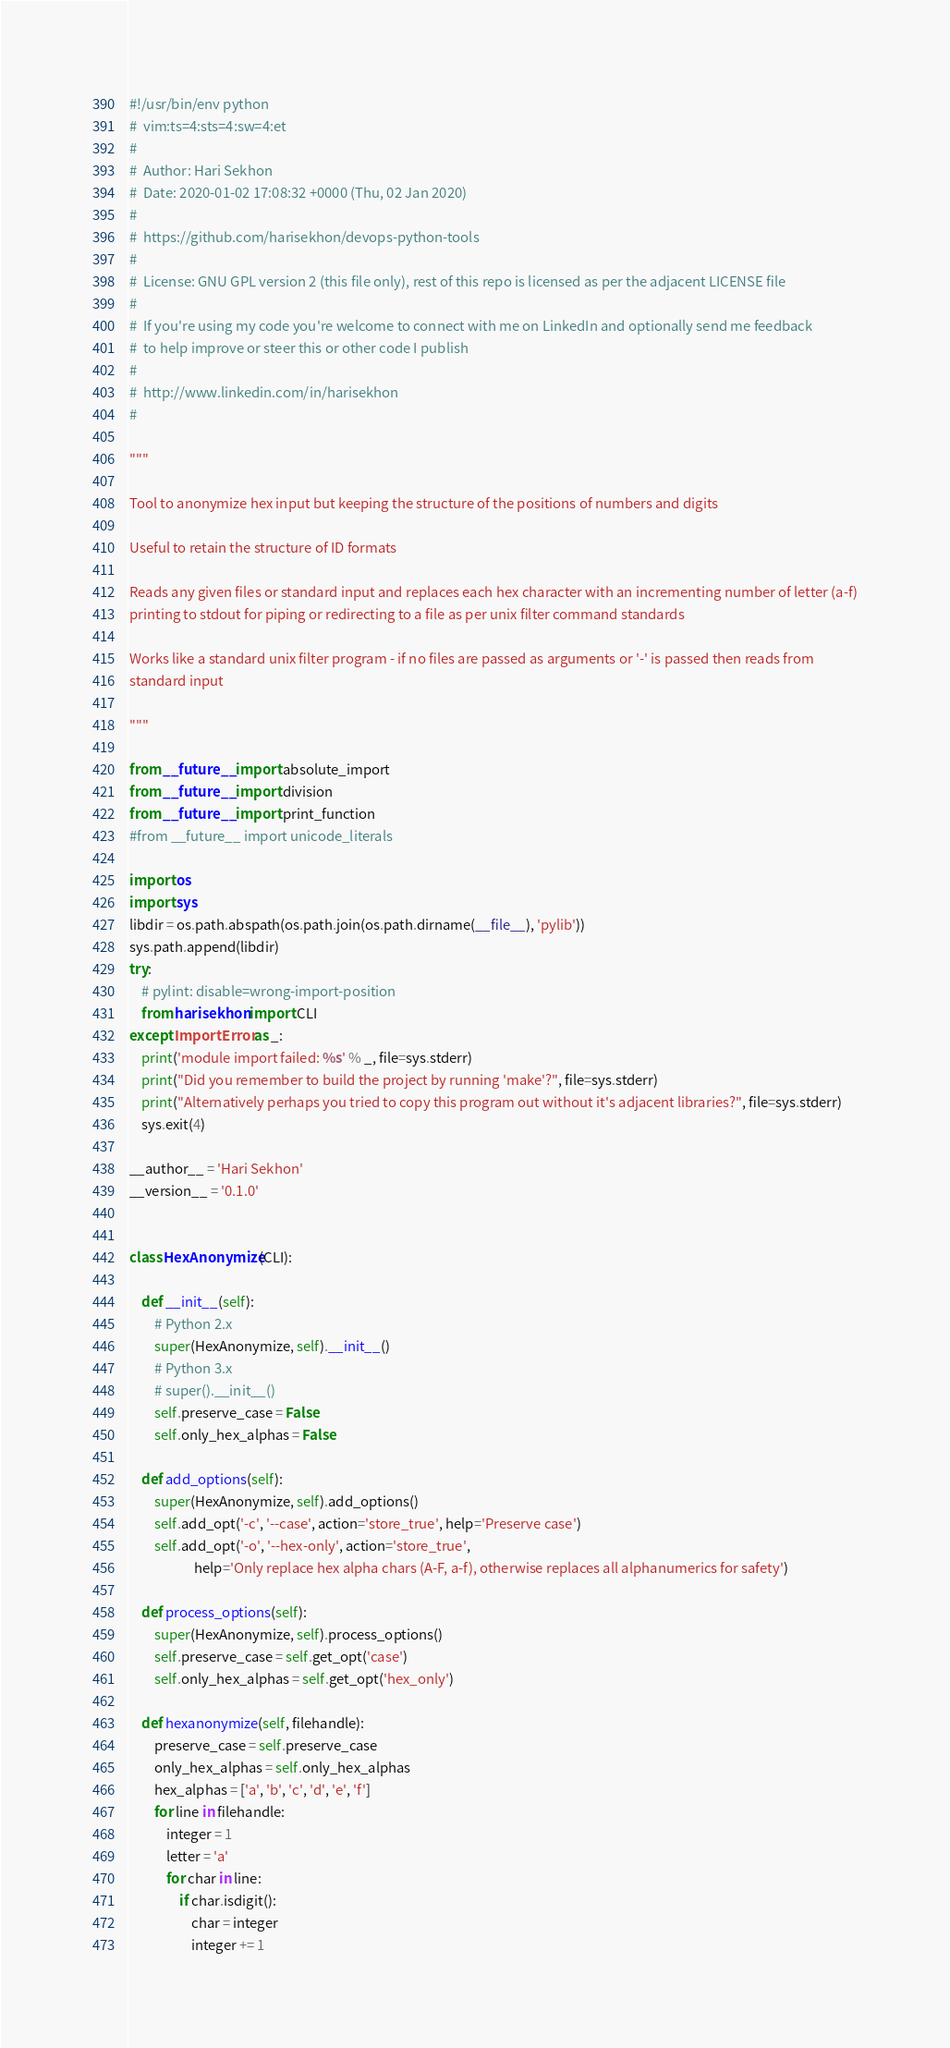<code> <loc_0><loc_0><loc_500><loc_500><_Python_>#!/usr/bin/env python
#  vim:ts=4:sts=4:sw=4:et
#
#  Author: Hari Sekhon
#  Date: 2020-01-02 17:08:32 +0000 (Thu, 02 Jan 2020)
#
#  https://github.com/harisekhon/devops-python-tools
#
#  License: GNU GPL version 2 (this file only), rest of this repo is licensed as per the adjacent LICENSE file
#
#  If you're using my code you're welcome to connect with me on LinkedIn and optionally send me feedback
#  to help improve or steer this or other code I publish
#
#  http://www.linkedin.com/in/harisekhon
#

"""

Tool to anonymize hex input but keeping the structure of the positions of numbers and digits

Useful to retain the structure of ID formats

Reads any given files or standard input and replaces each hex character with an incrementing number of letter (a-f)
printing to stdout for piping or redirecting to a file as per unix filter command standards

Works like a standard unix filter program - if no files are passed as arguments or '-' is passed then reads from
standard input

"""

from __future__ import absolute_import
from __future__ import division
from __future__ import print_function
#from __future__ import unicode_literals

import os
import sys
libdir = os.path.abspath(os.path.join(os.path.dirname(__file__), 'pylib'))
sys.path.append(libdir)
try:
    # pylint: disable=wrong-import-position
    from harisekhon import CLI
except ImportError as _:
    print('module import failed: %s' % _, file=sys.stderr)
    print("Did you remember to build the project by running 'make'?", file=sys.stderr)
    print("Alternatively perhaps you tried to copy this program out without it's adjacent libraries?", file=sys.stderr)
    sys.exit(4)

__author__ = 'Hari Sekhon'
__version__ = '0.1.0'


class HexAnonymize(CLI):

    def __init__(self):
        # Python 2.x
        super(HexAnonymize, self).__init__()
        # Python 3.x
        # super().__init__()
        self.preserve_case = False
        self.only_hex_alphas = False

    def add_options(self):
        super(HexAnonymize, self).add_options()
        self.add_opt('-c', '--case', action='store_true', help='Preserve case')
        self.add_opt('-o', '--hex-only', action='store_true',
                     help='Only replace hex alpha chars (A-F, a-f), otherwise replaces all alphanumerics for safety')

    def process_options(self):
        super(HexAnonymize, self).process_options()
        self.preserve_case = self.get_opt('case')
        self.only_hex_alphas = self.get_opt('hex_only')

    def hexanonymize(self, filehandle):
        preserve_case = self.preserve_case
        only_hex_alphas = self.only_hex_alphas
        hex_alphas = ['a', 'b', 'c', 'd', 'e', 'f']
        for line in filehandle:
            integer = 1
            letter = 'a'
            for char in line:
                if char.isdigit():
                    char = integer
                    integer += 1</code> 